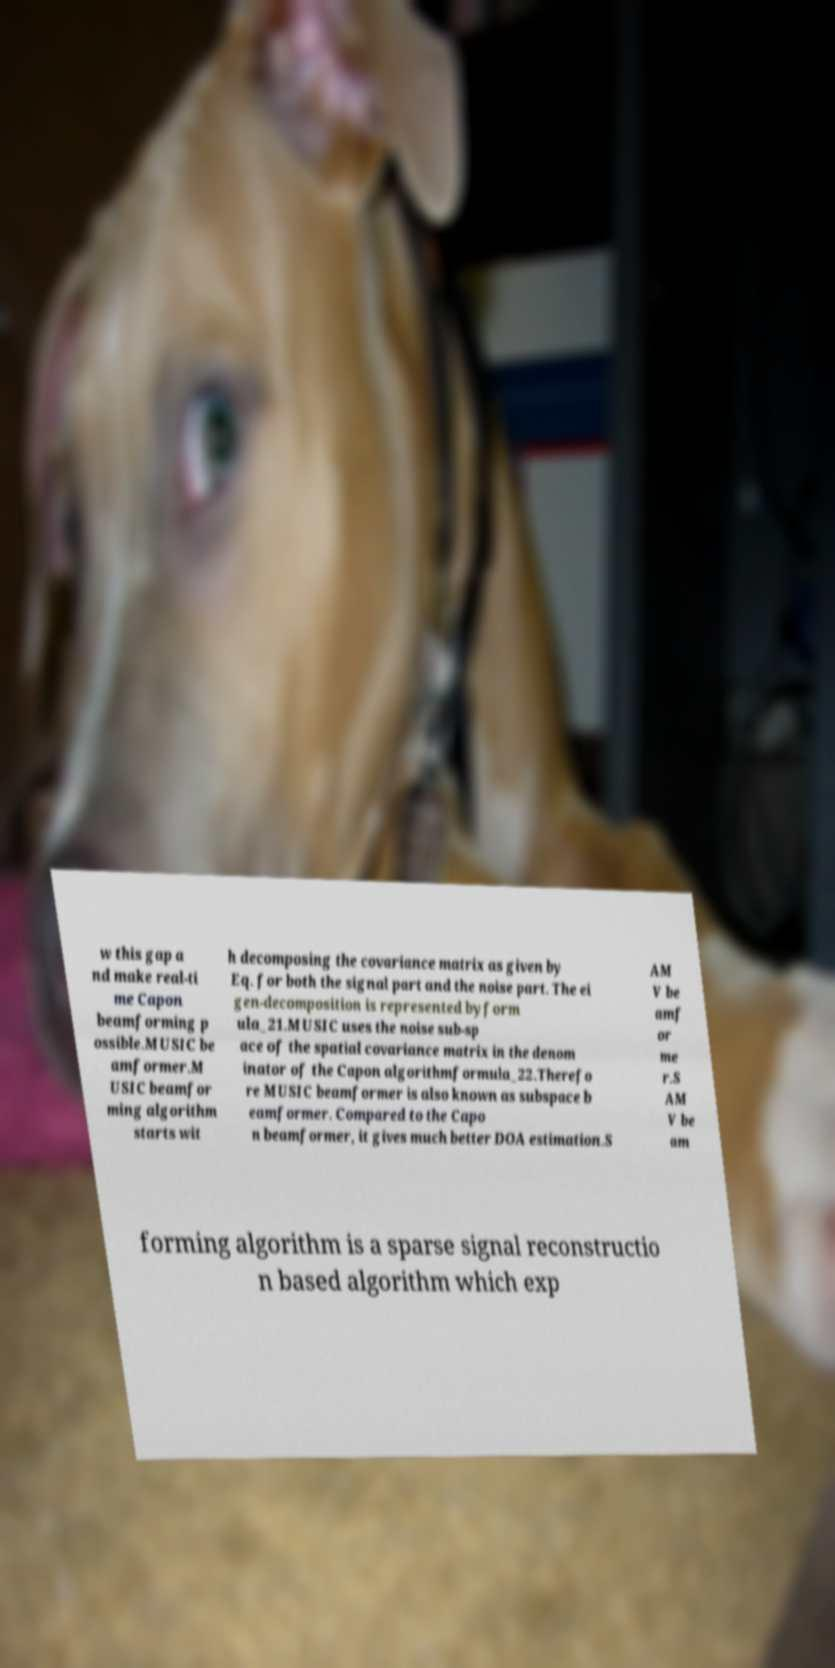Please identify and transcribe the text found in this image. w this gap a nd make real-ti me Capon beamforming p ossible.MUSIC be amformer.M USIC beamfor ming algorithm starts wit h decomposing the covariance matrix as given by Eq. for both the signal part and the noise part. The ei gen-decomposition is represented byform ula_21.MUSIC uses the noise sub-sp ace of the spatial covariance matrix in the denom inator of the Capon algorithmformula_22.Therefo re MUSIC beamformer is also known as subspace b eamformer. Compared to the Capo n beamformer, it gives much better DOA estimation.S AM V be amf or me r.S AM V be am forming algorithm is a sparse signal reconstructio n based algorithm which exp 